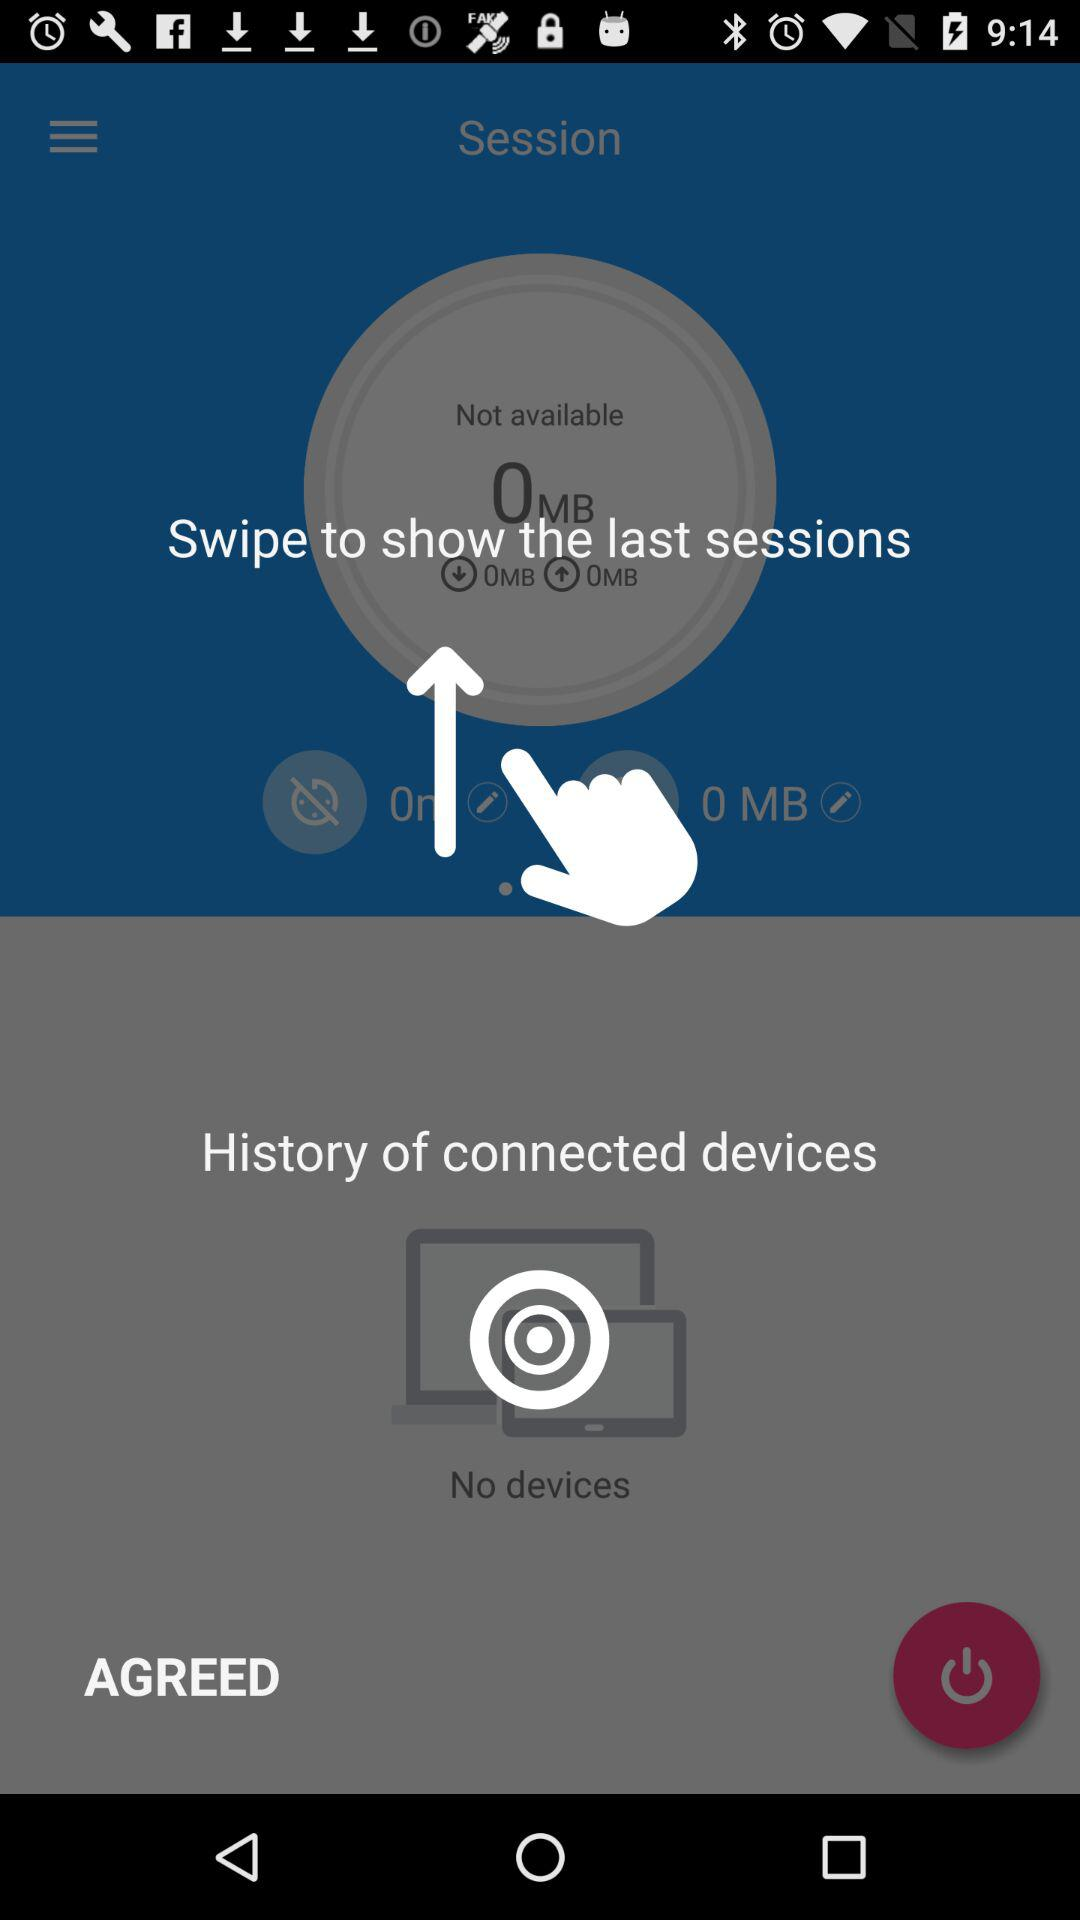How many MB of data is available?
Answer the question using a single word or phrase. 0 MB 